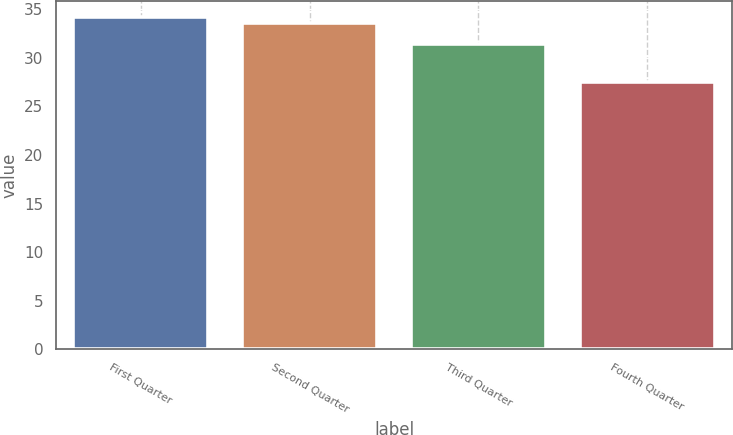<chart> <loc_0><loc_0><loc_500><loc_500><bar_chart><fcel>First Quarter<fcel>Second Quarter<fcel>Third Quarter<fcel>Fourth Quarter<nl><fcel>34.18<fcel>33.56<fcel>31.47<fcel>27.55<nl></chart> 